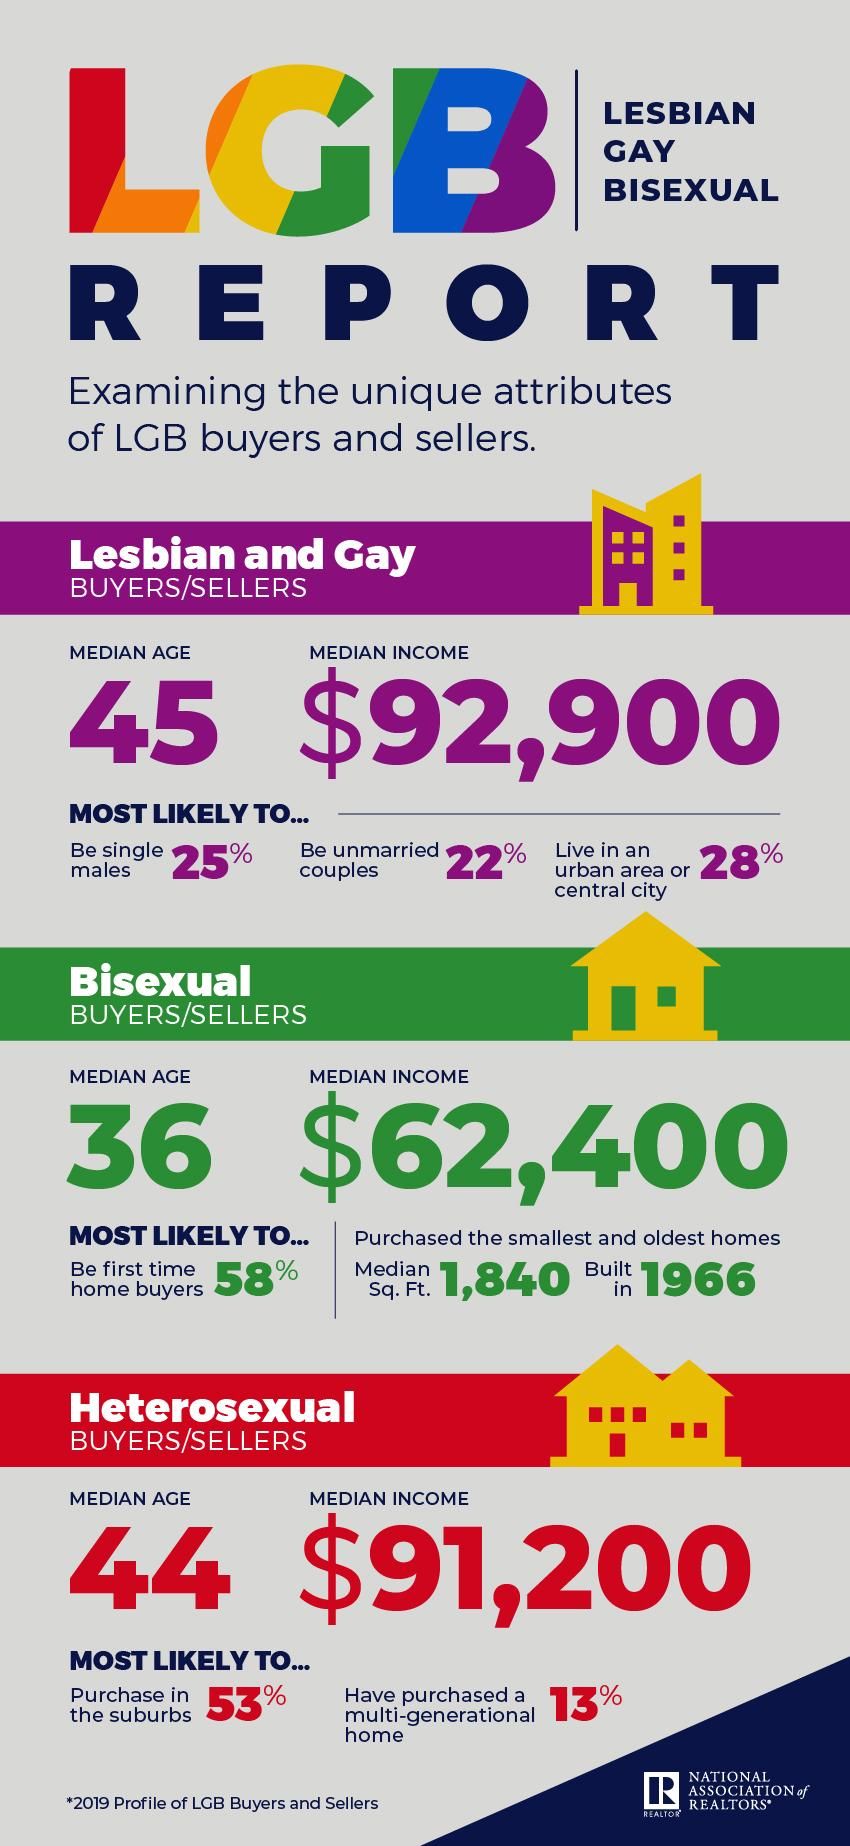Outline some significant characteristics in this image. The total median income among all categories of buyers and sellers is 246,500. The median age gap between lesbian, gay, bisexual buyers or sellers and others is unknown. Heterosexual buyers are the most likely to purchase multi-generational homes. Lesbian and gay buyers and sellers are likely to reside in urban areas, whereas heterosexual individuals may reside in both urban and rural areas. 